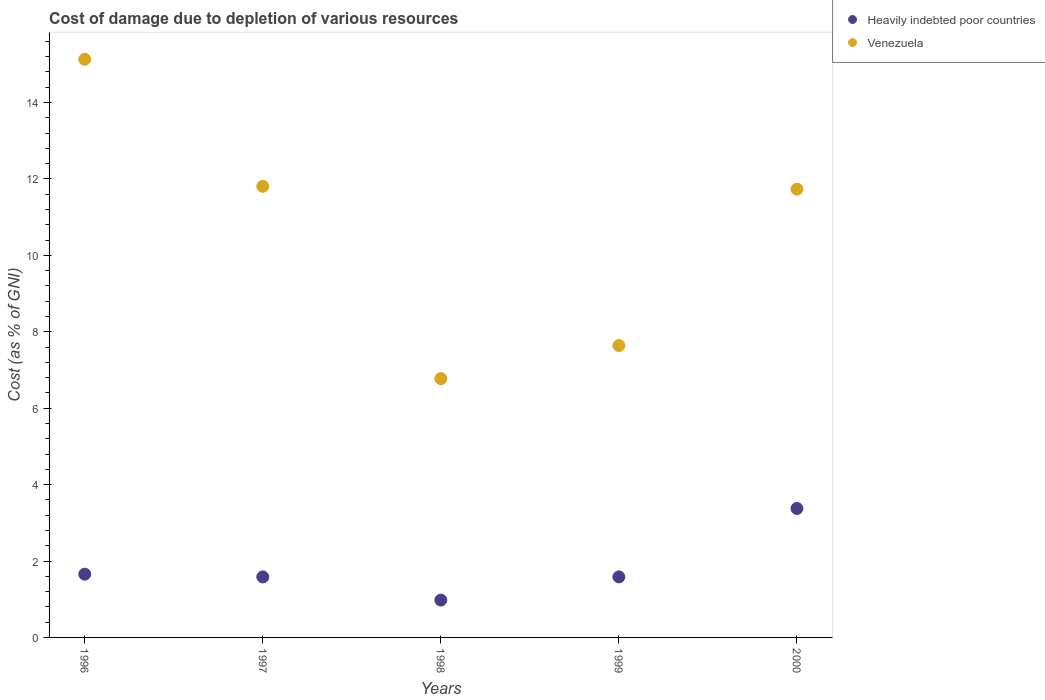How many different coloured dotlines are there?
Provide a succinct answer. 2. Is the number of dotlines equal to the number of legend labels?
Offer a very short reply. Yes. What is the cost of damage caused due to the depletion of various resources in Heavily indebted poor countries in 1996?
Give a very brief answer. 1.65. Across all years, what is the maximum cost of damage caused due to the depletion of various resources in Venezuela?
Offer a terse response. 15.13. Across all years, what is the minimum cost of damage caused due to the depletion of various resources in Heavily indebted poor countries?
Your answer should be compact. 0.98. In which year was the cost of damage caused due to the depletion of various resources in Venezuela minimum?
Your answer should be very brief. 1998. What is the total cost of damage caused due to the depletion of various resources in Heavily indebted poor countries in the graph?
Keep it short and to the point. 9.17. What is the difference between the cost of damage caused due to the depletion of various resources in Venezuela in 1996 and that in 1997?
Provide a succinct answer. 3.32. What is the difference between the cost of damage caused due to the depletion of various resources in Venezuela in 1998 and the cost of damage caused due to the depletion of various resources in Heavily indebted poor countries in 1999?
Offer a very short reply. 5.19. What is the average cost of damage caused due to the depletion of various resources in Venezuela per year?
Give a very brief answer. 10.62. In the year 1999, what is the difference between the cost of damage caused due to the depletion of various resources in Venezuela and cost of damage caused due to the depletion of various resources in Heavily indebted poor countries?
Offer a terse response. 6.05. In how many years, is the cost of damage caused due to the depletion of various resources in Heavily indebted poor countries greater than 6 %?
Make the answer very short. 0. What is the ratio of the cost of damage caused due to the depletion of various resources in Heavily indebted poor countries in 1996 to that in 1999?
Your response must be concise. 1.04. What is the difference between the highest and the second highest cost of damage caused due to the depletion of various resources in Heavily indebted poor countries?
Your response must be concise. 1.72. What is the difference between the highest and the lowest cost of damage caused due to the depletion of various resources in Heavily indebted poor countries?
Ensure brevity in your answer.  2.4. Is the cost of damage caused due to the depletion of various resources in Heavily indebted poor countries strictly greater than the cost of damage caused due to the depletion of various resources in Venezuela over the years?
Provide a succinct answer. No. Is the cost of damage caused due to the depletion of various resources in Venezuela strictly less than the cost of damage caused due to the depletion of various resources in Heavily indebted poor countries over the years?
Offer a terse response. No. How many years are there in the graph?
Give a very brief answer. 5. Are the values on the major ticks of Y-axis written in scientific E-notation?
Your answer should be compact. No. Does the graph contain any zero values?
Keep it short and to the point. No. Does the graph contain grids?
Your answer should be compact. No. Where does the legend appear in the graph?
Provide a succinct answer. Top right. How many legend labels are there?
Offer a very short reply. 2. What is the title of the graph?
Offer a terse response. Cost of damage due to depletion of various resources. Does "Malawi" appear as one of the legend labels in the graph?
Your response must be concise. No. What is the label or title of the X-axis?
Keep it short and to the point. Years. What is the label or title of the Y-axis?
Make the answer very short. Cost (as % of GNI). What is the Cost (as % of GNI) of Heavily indebted poor countries in 1996?
Offer a very short reply. 1.65. What is the Cost (as % of GNI) in Venezuela in 1996?
Your answer should be compact. 15.13. What is the Cost (as % of GNI) of Heavily indebted poor countries in 1997?
Your response must be concise. 1.58. What is the Cost (as % of GNI) in Venezuela in 1997?
Provide a short and direct response. 11.81. What is the Cost (as % of GNI) in Heavily indebted poor countries in 1998?
Keep it short and to the point. 0.98. What is the Cost (as % of GNI) in Venezuela in 1998?
Provide a short and direct response. 6.77. What is the Cost (as % of GNI) in Heavily indebted poor countries in 1999?
Make the answer very short. 1.58. What is the Cost (as % of GNI) of Venezuela in 1999?
Offer a terse response. 7.64. What is the Cost (as % of GNI) of Heavily indebted poor countries in 2000?
Offer a very short reply. 3.37. What is the Cost (as % of GNI) of Venezuela in 2000?
Your response must be concise. 11.73. Across all years, what is the maximum Cost (as % of GNI) of Heavily indebted poor countries?
Provide a succinct answer. 3.37. Across all years, what is the maximum Cost (as % of GNI) of Venezuela?
Keep it short and to the point. 15.13. Across all years, what is the minimum Cost (as % of GNI) of Heavily indebted poor countries?
Give a very brief answer. 0.98. Across all years, what is the minimum Cost (as % of GNI) of Venezuela?
Make the answer very short. 6.77. What is the total Cost (as % of GNI) of Heavily indebted poor countries in the graph?
Offer a very short reply. 9.17. What is the total Cost (as % of GNI) of Venezuela in the graph?
Keep it short and to the point. 53.08. What is the difference between the Cost (as % of GNI) of Heavily indebted poor countries in 1996 and that in 1997?
Provide a succinct answer. 0.07. What is the difference between the Cost (as % of GNI) of Venezuela in 1996 and that in 1997?
Your response must be concise. 3.32. What is the difference between the Cost (as % of GNI) of Heavily indebted poor countries in 1996 and that in 1998?
Your answer should be compact. 0.68. What is the difference between the Cost (as % of GNI) of Venezuela in 1996 and that in 1998?
Your answer should be compact. 8.36. What is the difference between the Cost (as % of GNI) in Heavily indebted poor countries in 1996 and that in 1999?
Provide a succinct answer. 0.07. What is the difference between the Cost (as % of GNI) in Venezuela in 1996 and that in 1999?
Your answer should be compact. 7.49. What is the difference between the Cost (as % of GNI) of Heavily indebted poor countries in 1996 and that in 2000?
Provide a short and direct response. -1.72. What is the difference between the Cost (as % of GNI) in Venezuela in 1996 and that in 2000?
Make the answer very short. 3.4. What is the difference between the Cost (as % of GNI) of Heavily indebted poor countries in 1997 and that in 1998?
Keep it short and to the point. 0.61. What is the difference between the Cost (as % of GNI) of Venezuela in 1997 and that in 1998?
Your answer should be compact. 5.03. What is the difference between the Cost (as % of GNI) of Heavily indebted poor countries in 1997 and that in 1999?
Provide a succinct answer. -0. What is the difference between the Cost (as % of GNI) of Venezuela in 1997 and that in 1999?
Keep it short and to the point. 4.17. What is the difference between the Cost (as % of GNI) of Heavily indebted poor countries in 1997 and that in 2000?
Ensure brevity in your answer.  -1.79. What is the difference between the Cost (as % of GNI) in Venezuela in 1997 and that in 2000?
Your answer should be very brief. 0.08. What is the difference between the Cost (as % of GNI) of Heavily indebted poor countries in 1998 and that in 1999?
Your response must be concise. -0.61. What is the difference between the Cost (as % of GNI) of Venezuela in 1998 and that in 1999?
Give a very brief answer. -0.86. What is the difference between the Cost (as % of GNI) of Heavily indebted poor countries in 1998 and that in 2000?
Give a very brief answer. -2.4. What is the difference between the Cost (as % of GNI) in Venezuela in 1998 and that in 2000?
Offer a very short reply. -4.96. What is the difference between the Cost (as % of GNI) of Heavily indebted poor countries in 1999 and that in 2000?
Ensure brevity in your answer.  -1.79. What is the difference between the Cost (as % of GNI) of Venezuela in 1999 and that in 2000?
Make the answer very short. -4.09. What is the difference between the Cost (as % of GNI) in Heavily indebted poor countries in 1996 and the Cost (as % of GNI) in Venezuela in 1997?
Offer a very short reply. -10.15. What is the difference between the Cost (as % of GNI) of Heavily indebted poor countries in 1996 and the Cost (as % of GNI) of Venezuela in 1998?
Offer a very short reply. -5.12. What is the difference between the Cost (as % of GNI) of Heavily indebted poor countries in 1996 and the Cost (as % of GNI) of Venezuela in 1999?
Ensure brevity in your answer.  -5.98. What is the difference between the Cost (as % of GNI) in Heavily indebted poor countries in 1996 and the Cost (as % of GNI) in Venezuela in 2000?
Your response must be concise. -10.08. What is the difference between the Cost (as % of GNI) in Heavily indebted poor countries in 1997 and the Cost (as % of GNI) in Venezuela in 1998?
Your response must be concise. -5.19. What is the difference between the Cost (as % of GNI) in Heavily indebted poor countries in 1997 and the Cost (as % of GNI) in Venezuela in 1999?
Ensure brevity in your answer.  -6.05. What is the difference between the Cost (as % of GNI) in Heavily indebted poor countries in 1997 and the Cost (as % of GNI) in Venezuela in 2000?
Offer a terse response. -10.15. What is the difference between the Cost (as % of GNI) in Heavily indebted poor countries in 1998 and the Cost (as % of GNI) in Venezuela in 1999?
Your response must be concise. -6.66. What is the difference between the Cost (as % of GNI) of Heavily indebted poor countries in 1998 and the Cost (as % of GNI) of Venezuela in 2000?
Provide a succinct answer. -10.75. What is the difference between the Cost (as % of GNI) in Heavily indebted poor countries in 1999 and the Cost (as % of GNI) in Venezuela in 2000?
Give a very brief answer. -10.15. What is the average Cost (as % of GNI) of Heavily indebted poor countries per year?
Keep it short and to the point. 1.83. What is the average Cost (as % of GNI) in Venezuela per year?
Offer a very short reply. 10.62. In the year 1996, what is the difference between the Cost (as % of GNI) of Heavily indebted poor countries and Cost (as % of GNI) of Venezuela?
Offer a terse response. -13.47. In the year 1997, what is the difference between the Cost (as % of GNI) in Heavily indebted poor countries and Cost (as % of GNI) in Venezuela?
Your answer should be compact. -10.22. In the year 1998, what is the difference between the Cost (as % of GNI) in Heavily indebted poor countries and Cost (as % of GNI) in Venezuela?
Give a very brief answer. -5.8. In the year 1999, what is the difference between the Cost (as % of GNI) of Heavily indebted poor countries and Cost (as % of GNI) of Venezuela?
Offer a terse response. -6.05. In the year 2000, what is the difference between the Cost (as % of GNI) in Heavily indebted poor countries and Cost (as % of GNI) in Venezuela?
Offer a terse response. -8.36. What is the ratio of the Cost (as % of GNI) in Heavily indebted poor countries in 1996 to that in 1997?
Provide a short and direct response. 1.04. What is the ratio of the Cost (as % of GNI) of Venezuela in 1996 to that in 1997?
Give a very brief answer. 1.28. What is the ratio of the Cost (as % of GNI) in Heavily indebted poor countries in 1996 to that in 1998?
Your answer should be compact. 1.69. What is the ratio of the Cost (as % of GNI) of Venezuela in 1996 to that in 1998?
Offer a terse response. 2.23. What is the ratio of the Cost (as % of GNI) of Heavily indebted poor countries in 1996 to that in 1999?
Offer a terse response. 1.04. What is the ratio of the Cost (as % of GNI) of Venezuela in 1996 to that in 1999?
Offer a terse response. 1.98. What is the ratio of the Cost (as % of GNI) of Heavily indebted poor countries in 1996 to that in 2000?
Your answer should be compact. 0.49. What is the ratio of the Cost (as % of GNI) of Venezuela in 1996 to that in 2000?
Give a very brief answer. 1.29. What is the ratio of the Cost (as % of GNI) of Heavily indebted poor countries in 1997 to that in 1998?
Give a very brief answer. 1.62. What is the ratio of the Cost (as % of GNI) of Venezuela in 1997 to that in 1998?
Offer a very short reply. 1.74. What is the ratio of the Cost (as % of GNI) in Heavily indebted poor countries in 1997 to that in 1999?
Give a very brief answer. 1. What is the ratio of the Cost (as % of GNI) in Venezuela in 1997 to that in 1999?
Keep it short and to the point. 1.55. What is the ratio of the Cost (as % of GNI) of Heavily indebted poor countries in 1997 to that in 2000?
Ensure brevity in your answer.  0.47. What is the ratio of the Cost (as % of GNI) in Venezuela in 1997 to that in 2000?
Your answer should be compact. 1.01. What is the ratio of the Cost (as % of GNI) in Heavily indebted poor countries in 1998 to that in 1999?
Make the answer very short. 0.62. What is the ratio of the Cost (as % of GNI) in Venezuela in 1998 to that in 1999?
Your response must be concise. 0.89. What is the ratio of the Cost (as % of GNI) of Heavily indebted poor countries in 1998 to that in 2000?
Provide a succinct answer. 0.29. What is the ratio of the Cost (as % of GNI) in Venezuela in 1998 to that in 2000?
Ensure brevity in your answer.  0.58. What is the ratio of the Cost (as % of GNI) in Heavily indebted poor countries in 1999 to that in 2000?
Make the answer very short. 0.47. What is the ratio of the Cost (as % of GNI) of Venezuela in 1999 to that in 2000?
Your answer should be very brief. 0.65. What is the difference between the highest and the second highest Cost (as % of GNI) in Heavily indebted poor countries?
Make the answer very short. 1.72. What is the difference between the highest and the second highest Cost (as % of GNI) of Venezuela?
Your response must be concise. 3.32. What is the difference between the highest and the lowest Cost (as % of GNI) in Heavily indebted poor countries?
Your answer should be compact. 2.4. What is the difference between the highest and the lowest Cost (as % of GNI) of Venezuela?
Provide a succinct answer. 8.36. 